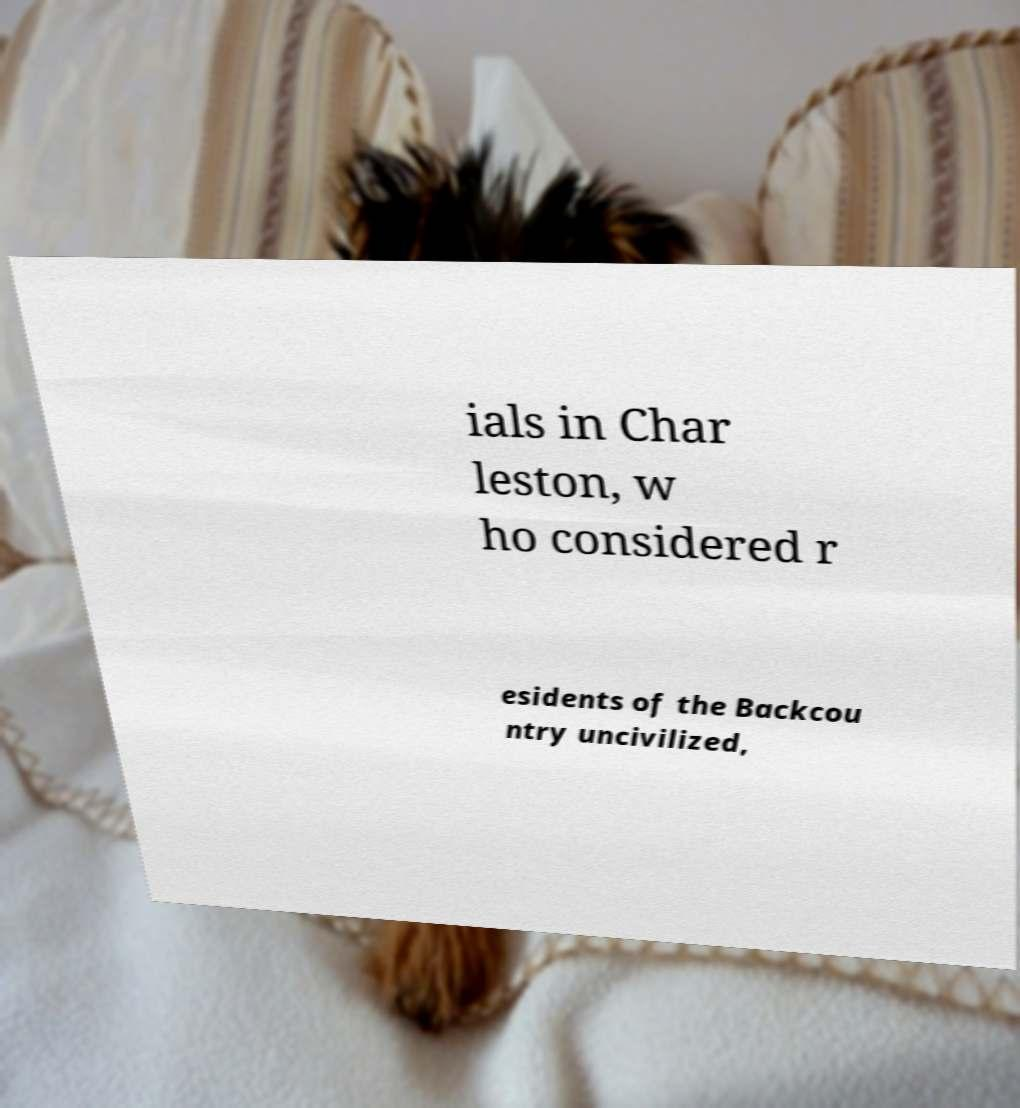Could you assist in decoding the text presented in this image and type it out clearly? ials in Char leston, w ho considered r esidents of the Backcou ntry uncivilized, 